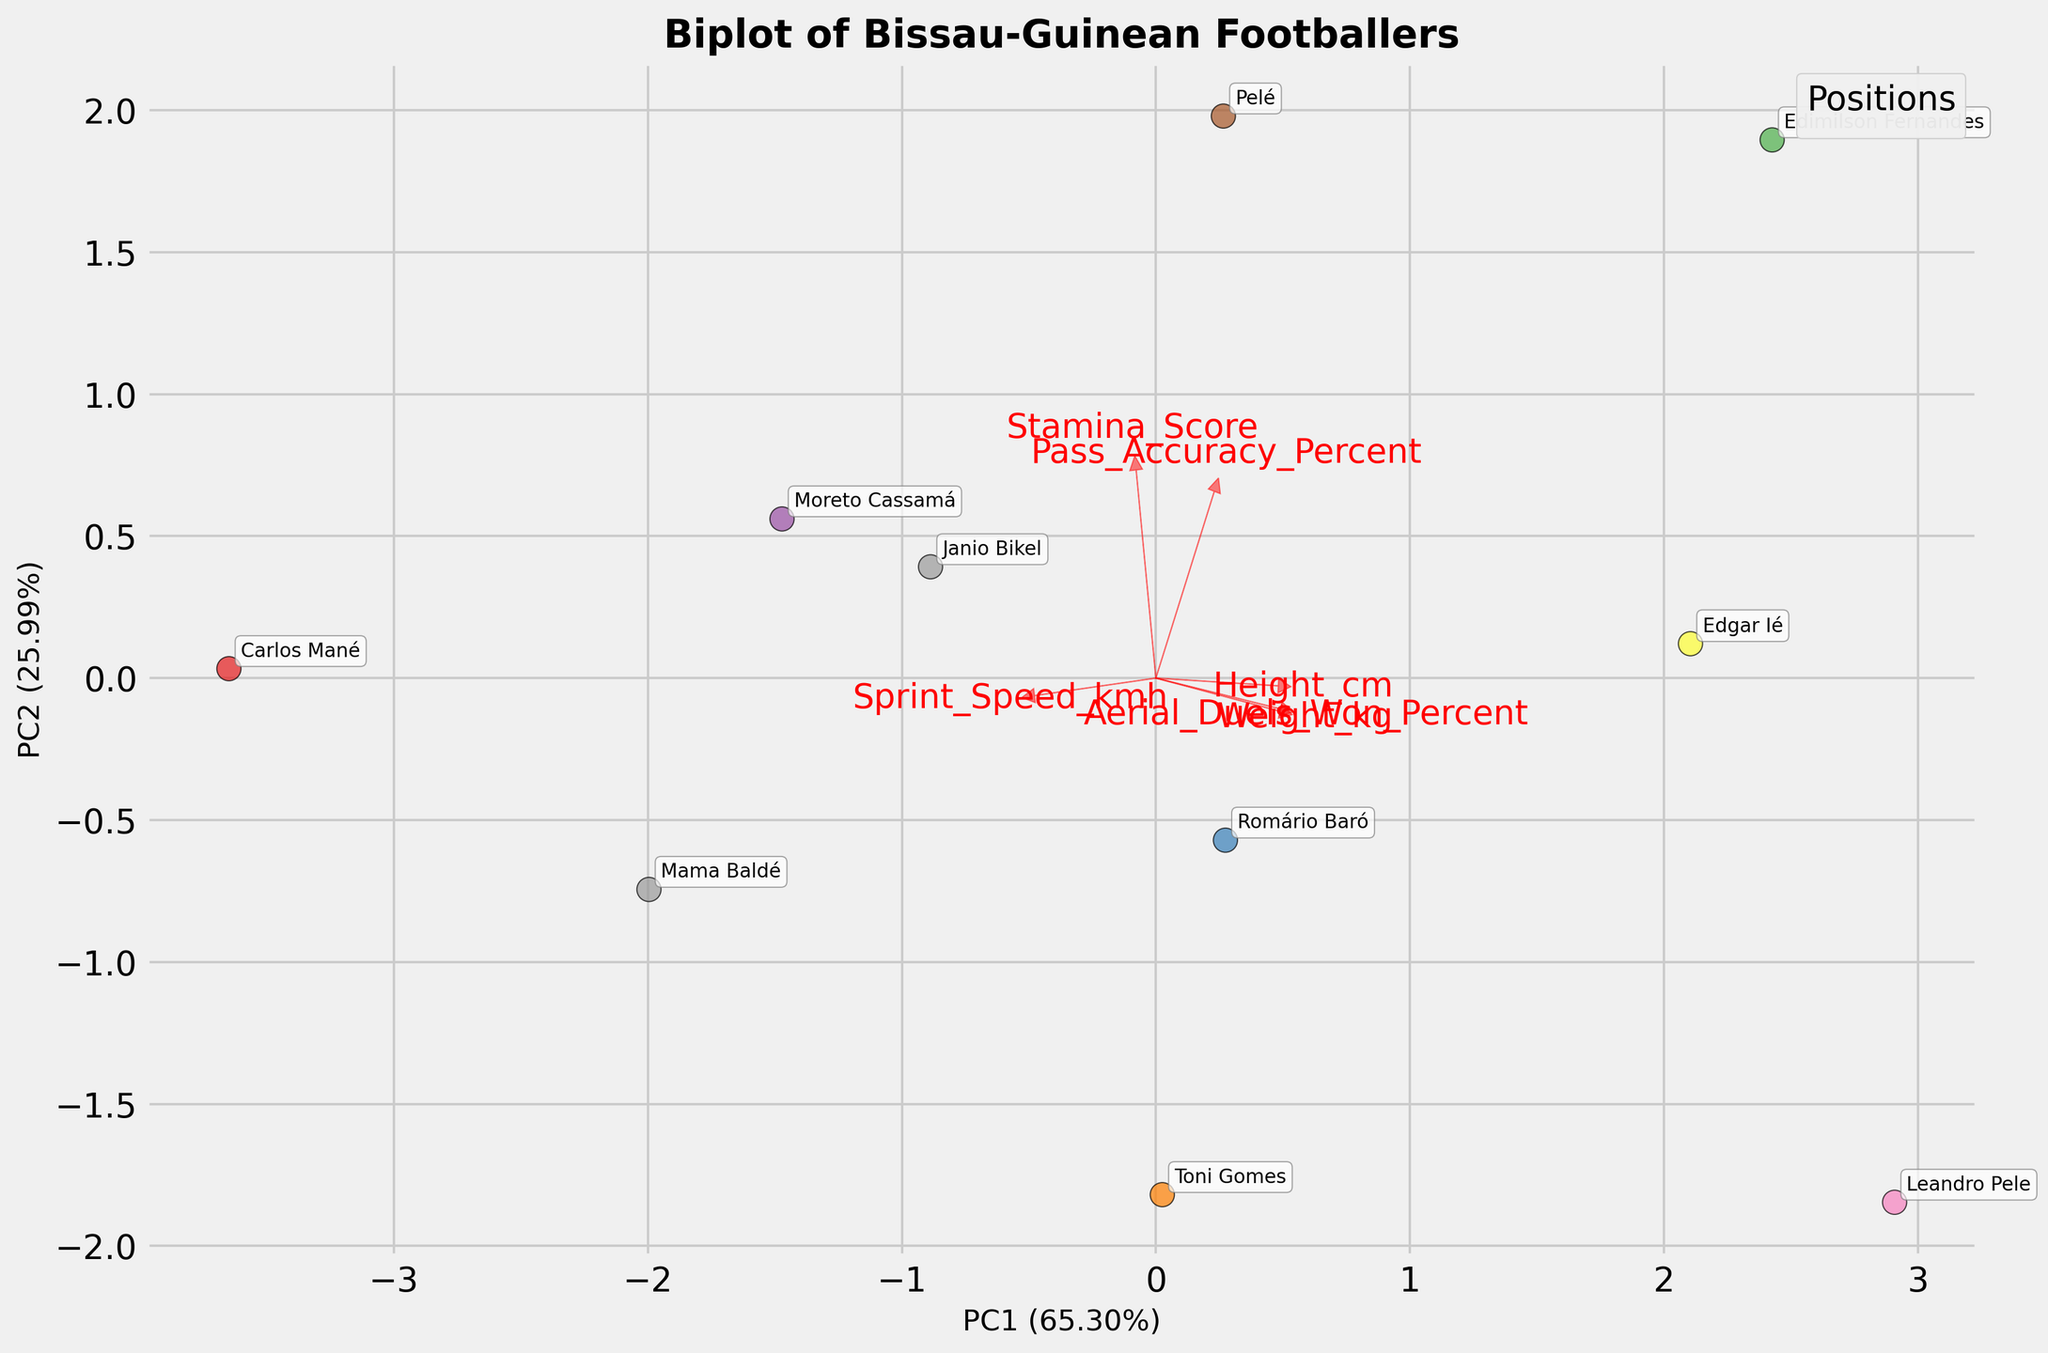How many different positions of footballers are represented on the biplot? Look at the legend located in the upper right corner of the biplot, where each color represents a different position. Count the number of unique positions listed there.
Answer: 4 Which player appears closest to the positive end of the arrow for 'Sprint_Speed_kmh'? Identify the arrow labeled 'Sprint_Speed_kmh' and find the player whose data point is closest to the direction the arrow points.
Answer: Carlos Mané Which feature vector has the longest arrow? Compare the lengths of all red arrows representing different feature vectors, identifying which one extends the farthest from the origin (0, 0).
Answer: Height_cm Who is the closest defender to the centroid (origin) of the biplot? Identify the positions of defenders on the plot and find the one whose data point is nearest to the center (0, 0).
Answer: Edgar Ié Between 'Pass_Accuracy_Percent' and 'Aerial_Duels_Won_Percent', which feature seems more aligned with the first principal component? Observe the red arrows representing 'Pass_Accuracy_Percent' and 'Aerial_Duels_Won_Percent' and note which one has a greater projection along the x-axis (PC1).
Answer: Pass_Accuracy_Percent Which player has the highest overall value for 'Stamina_Score'? Find the vector representing 'Stamina_Score' and then identify the player whose data point projects the farthest along its direction.
Answer: Edimilson Fernandes How are 'Height_cm' and 'Weight_kg' related according to the biplot? Look at the orientation of the arrows for 'Height_cm' and 'Weight_kg.' If they point in roughly the same direction, it indicates a positive correlation.
Answer: Positively Correlated Which positions occupy the most diverse regions in the PCA space? Observe the scattering of data points representing different positions. The position with the widest spread indicates the most diversity in terms of PCA scores.
Answer: Midfielder Who is the farthest winger from the origin, and in which direction from the centroid is he located? Locate all wingers on the plot and find the one furthest from the origin (0, 0). Assess the direction based on the position of the player's plot point relative to the center.
Answer: Carlos Mané, positive along PC1 Between 'Height_cm' and 'Sprint_Speed_kmh', which feature has more influence on PC2? Check the orientation and projection of the corresponding arrows along the y-axis (PC2). The feature with a greater projection along the y-axis influences PC2 more.
Answer: Height_cm 